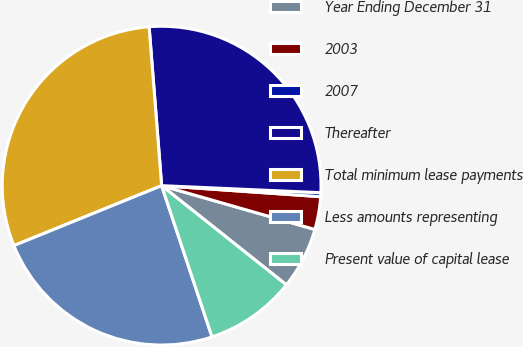Convert chart. <chart><loc_0><loc_0><loc_500><loc_500><pie_chart><fcel>Year Ending December 31<fcel>2003<fcel>2007<fcel>Thereafter<fcel>Total minimum lease payments<fcel>Less amounts representing<fcel>Present value of capital lease<nl><fcel>6.26%<fcel>3.33%<fcel>0.4%<fcel>26.96%<fcel>29.89%<fcel>23.99%<fcel>9.19%<nl></chart> 